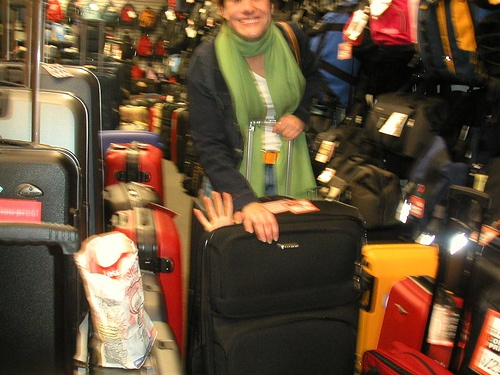Describe the objects in this image and their specific colors. I can see suitcase in black, maroon, gray, and brown tones, suitcase in black, tan, and orange tones, people in black, olive, darkgreen, and tan tones, suitcase in black and gray tones, and suitcase in black and gray tones in this image. 